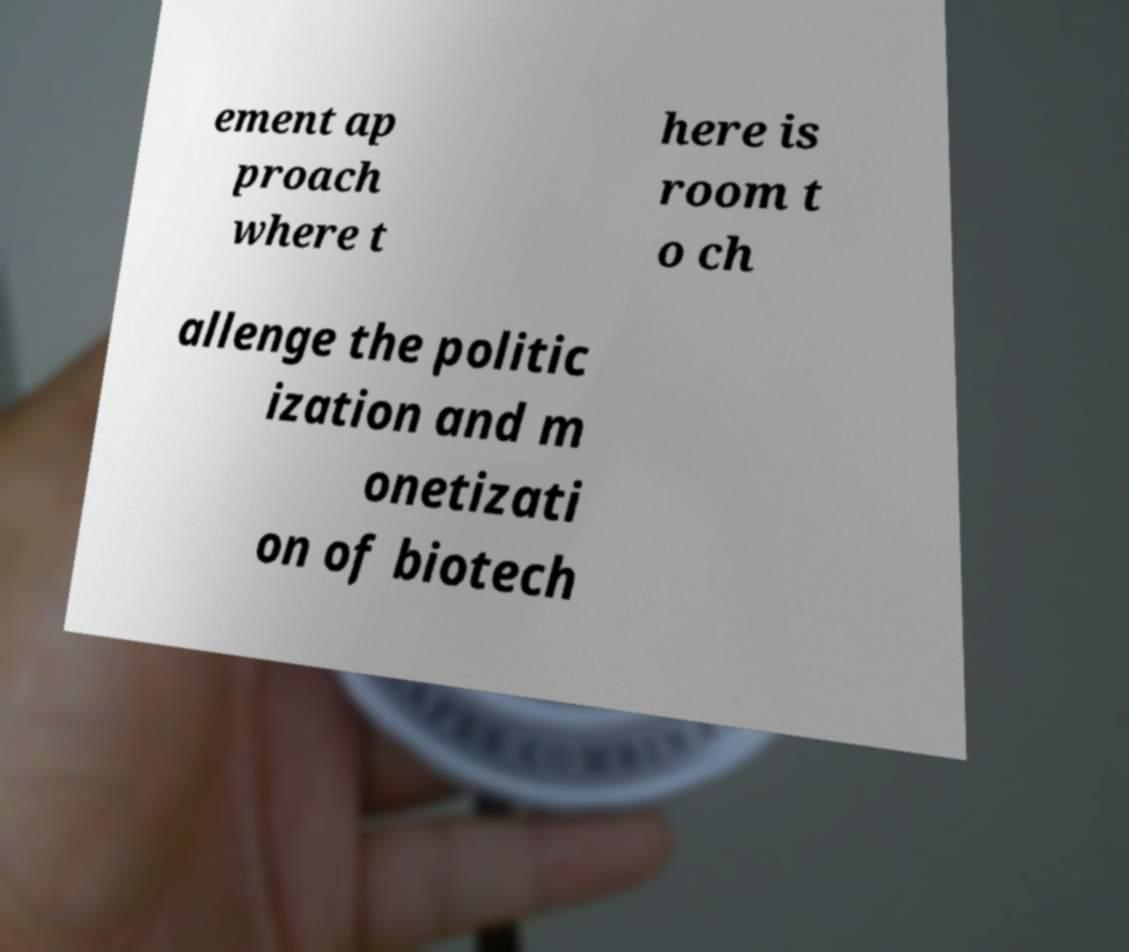Can you read and provide the text displayed in the image?This photo seems to have some interesting text. Can you extract and type it out for me? ement ap proach where t here is room t o ch allenge the politic ization and m onetizati on of biotech 